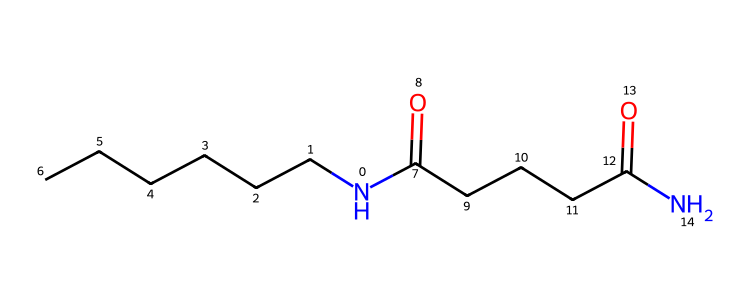What is the name of this chemical? The SMILES representation indicates that this chemical is a type of nylon, specifically a polyamide, due to the presence of amide functional groups (N-C=O) in the structure.
Answer: nylon How many carbon atoms are present in the structure? By analyzing the SMILES representation, we can count the carbon (C) atoms present in the linear sections. There are 12 carbon atoms in total: 6 from the first chain and 6 from the second.
Answer: 12 What type of linkage occurs between the monomers in this chemical? The presence of the amide groups (–C(=O)N–) shows that the linkages between monomers are amide linkages, which emerge from the reaction of carboxylic acids and amines.
Answer: amide Is this chemical likely to be hydrophilic or hydrophobic? Given the presence of multiple amide groups that can interact with water through hydrogen bonding, this chemical has hydrophilic characteristics, even though it has long hydrophobic carbon chains.
Answer: hydrophilic What type of polymer is formed by this structure? This structure represents a condensation polymer where water is released during the polymerization process (due to the formation of amide bonds), categorizing it as a condensation polymer.
Answer: condensation polymer 